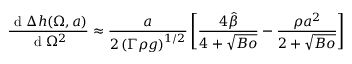Convert formula to latex. <formula><loc_0><loc_0><loc_500><loc_500>\frac { d \Delta { h } ( \Omega , a ) } { d \Omega ^ { 2 } } \approx \frac { a } { 2 \left ( \Gamma \rho { g } \right ) ^ { 1 / 2 } } \left [ \frac { 4 \hat { \beta } } { 4 + \sqrt { B o } } - \frac { \rho { a } ^ { 2 } } { 2 + \sqrt { B o } } \right ]</formula> 